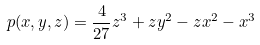<formula> <loc_0><loc_0><loc_500><loc_500>p ( x , y , z ) = \frac { 4 } { 2 7 } z ^ { 3 } + z y ^ { 2 } - z x ^ { 2 } - x ^ { 3 }</formula> 